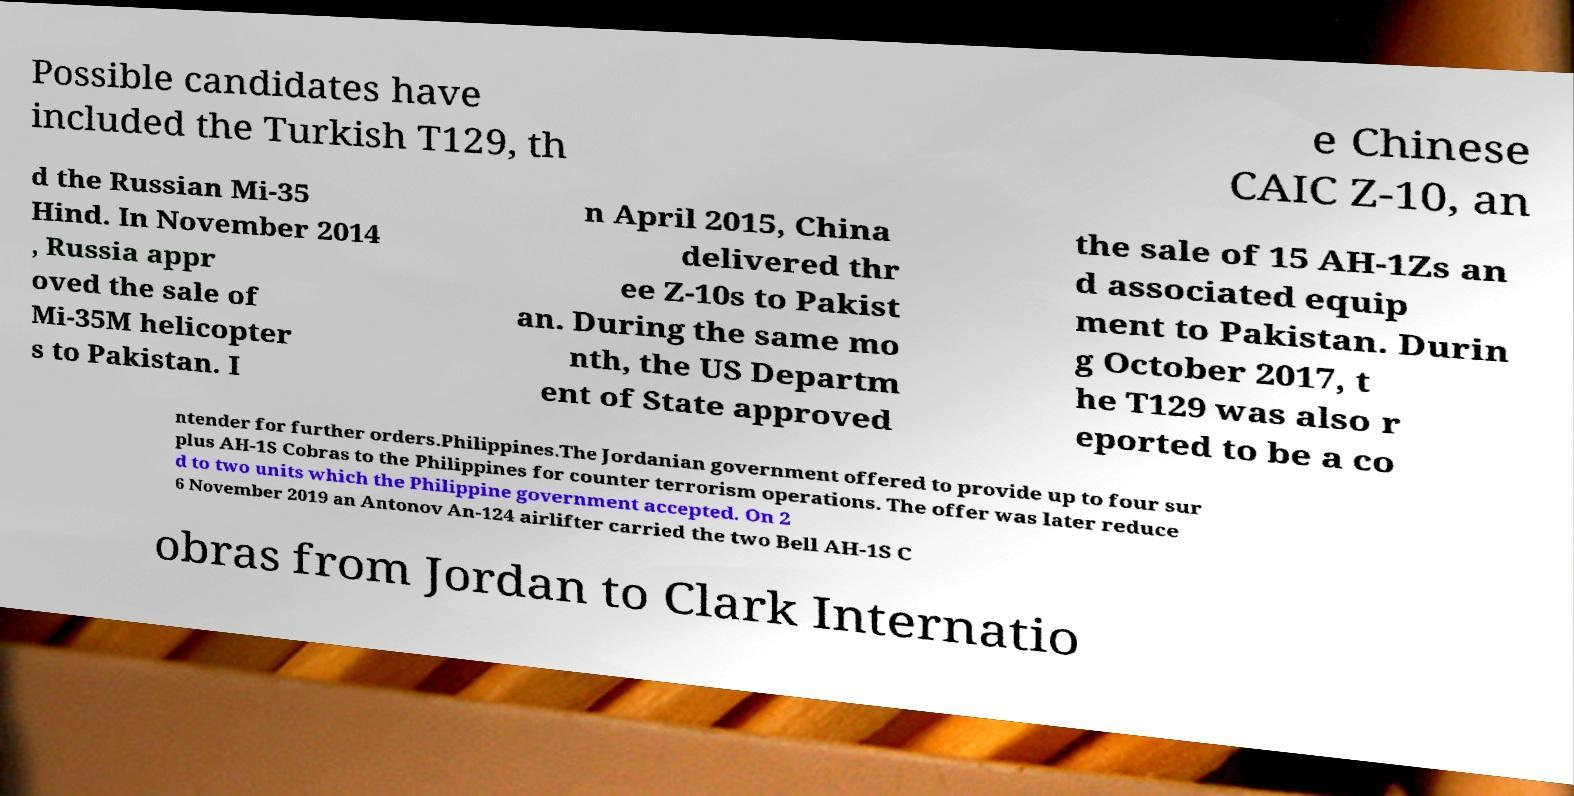I need the written content from this picture converted into text. Can you do that? Possible candidates have included the Turkish T129, th e Chinese CAIC Z-10, an d the Russian Mi-35 Hind. In November 2014 , Russia appr oved the sale of Mi-35M helicopter s to Pakistan. I n April 2015, China delivered thr ee Z-10s to Pakist an. During the same mo nth, the US Departm ent of State approved the sale of 15 AH-1Zs an d associated equip ment to Pakistan. Durin g October 2017, t he T129 was also r eported to be a co ntender for further orders.Philippines.The Jordanian government offered to provide up to four sur plus AH-1S Cobras to the Philippines for counter terrorism operations. The offer was later reduce d to two units which the Philippine government accepted. On 2 6 November 2019 an Antonov An-124 airlifter carried the two Bell AH-1S C obras from Jordan to Clark Internatio 